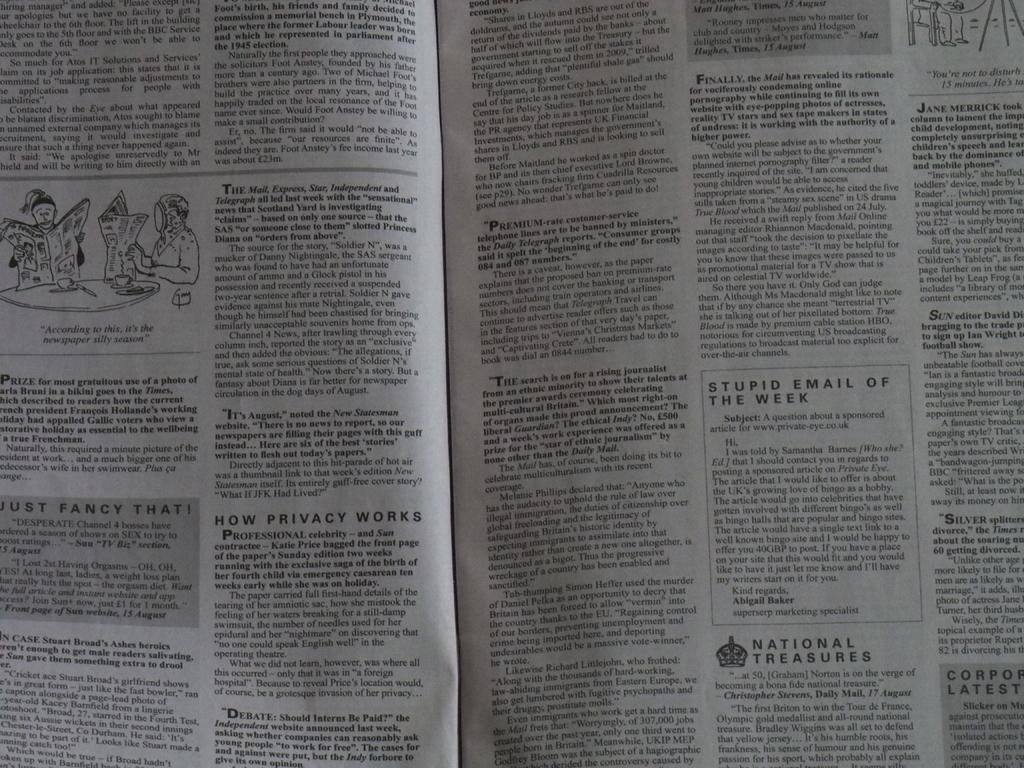<image>
Give a short and clear explanation of the subsequent image. A newspaper is open to a section called How Privacy Works. 